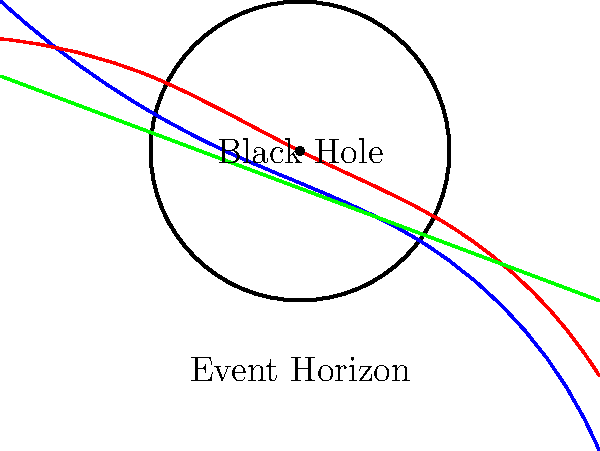During a family game night, you're playing a space-themed board game with your kids. You land on a "Black Hole Challenge" square, which asks: "Which colored light path in the image most accurately represents the behavior of light near a black hole's event horizon, and why?" Let's break this down step-by-step:

1. In the image, we see three colored paths representing light rays near a black hole:
   - Blue path (most curved)
   - Red path (moderately curved)
   - Green path (straight line)

2. Near a black hole, space-time is severely warped due to the intense gravitational field. This warping affects the path of light.

3. According to Einstein's theory of general relativity, light follows the curvature of space-time. The closer light gets to a massive object like a black hole, the more its path will bend.

4. The event horizon is the boundary around a black hole beyond which nothing, not even light, can escape. Light that passes very close to (but not within) the event horizon will be dramatically curved by the black hole's gravity.

5. Looking at our options:
   - The green path shows no curvature, which is incorrect near a black hole.
   - The red path shows some curvature, which is better but not extreme enough.
   - The blue path shows the most dramatic curvature, nearly circling the black hole before escaping.

6. The blue path most accurately represents how light behaves near a black hole's event horizon. It demonstrates the extreme bending of light's path due to the intense gravitational field, without crossing the event horizon (which would result in the light not escaping at all).
Answer: Blue path 